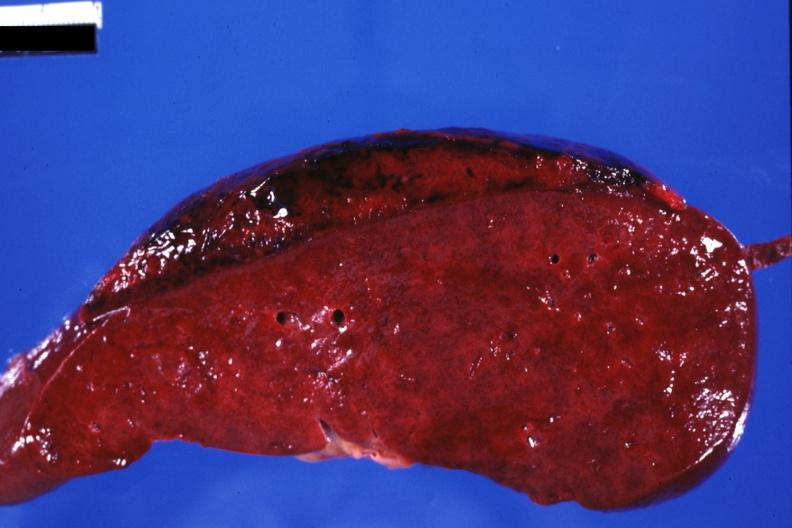does anomalous origin show sectioned spleen showing lesion very well?
Answer the question using a single word or phrase. No 